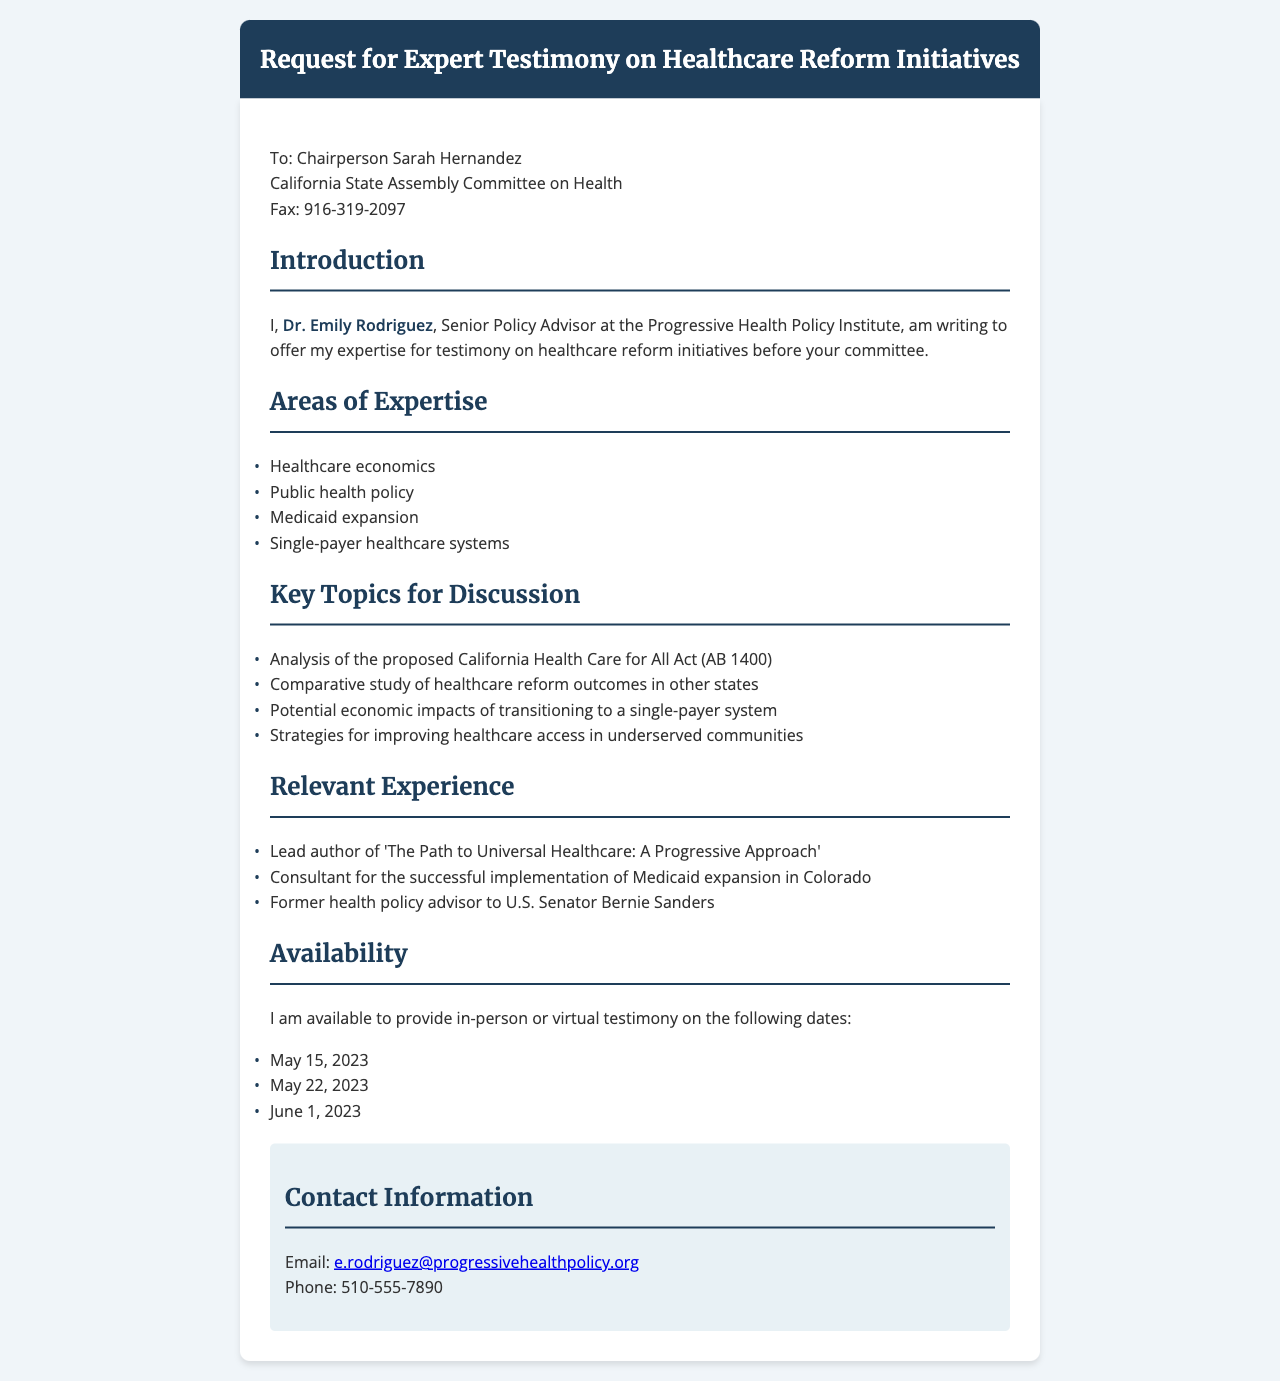What is the name of the sender of the fax? The sender of the fax is Dr. Emily Rodriguez, as mentioned in the introduction section.
Answer: Dr. Emily Rodriguez Who is the recipient of the fax? The recipient is Chairperson Sarah Hernandez of the California State Assembly Committee on Health, stated at the beginning of the document.
Answer: Chairperson Sarah Hernandez What is one of the areas of expertise mentioned? The document lists several areas of expertise, one of which is healthcare economics.
Answer: Healthcare economics What date is Dr. Emily Rodriguez available for testimony? The document provides multiple dates, including May 15, 2023, as one of the available options.
Answer: May 15, 2023 What is the title of the relevant publication authored by Dr. Emily Rodriguez? The document refers to the publication titled "The Path to Universal Healthcare: A Progressive Approach" in the experience section.
Answer: The Path to Universal Healthcare: A Progressive Approach What is the proposed legislation discussed in the fax? The fax mentions the California Health Care for All Act (AB 1400) as a key topic for discussion.
Answer: California Health Care for All Act (AB 1400) What is the fax number listed for the committee? The document states the fax number for the committee is 916-319-2097.
Answer: 916-319-2097 What type of healthcare system is discussed as a potential reform? The document refers to transitioning to a single-payer healthcare system as a key topic.
Answer: Single-payer healthcare system 